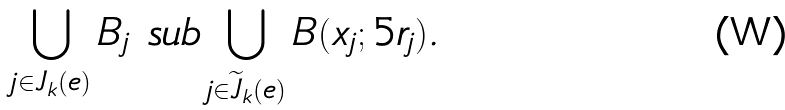Convert formula to latex. <formula><loc_0><loc_0><loc_500><loc_500>\bigcup _ { j \in J _ { k } ( e ) } B _ { j } \ s u b \bigcup _ { j \in \widetilde { J } _ { k } ( e ) } B ( x _ { j } ; 5 r _ { j } ) .</formula> 